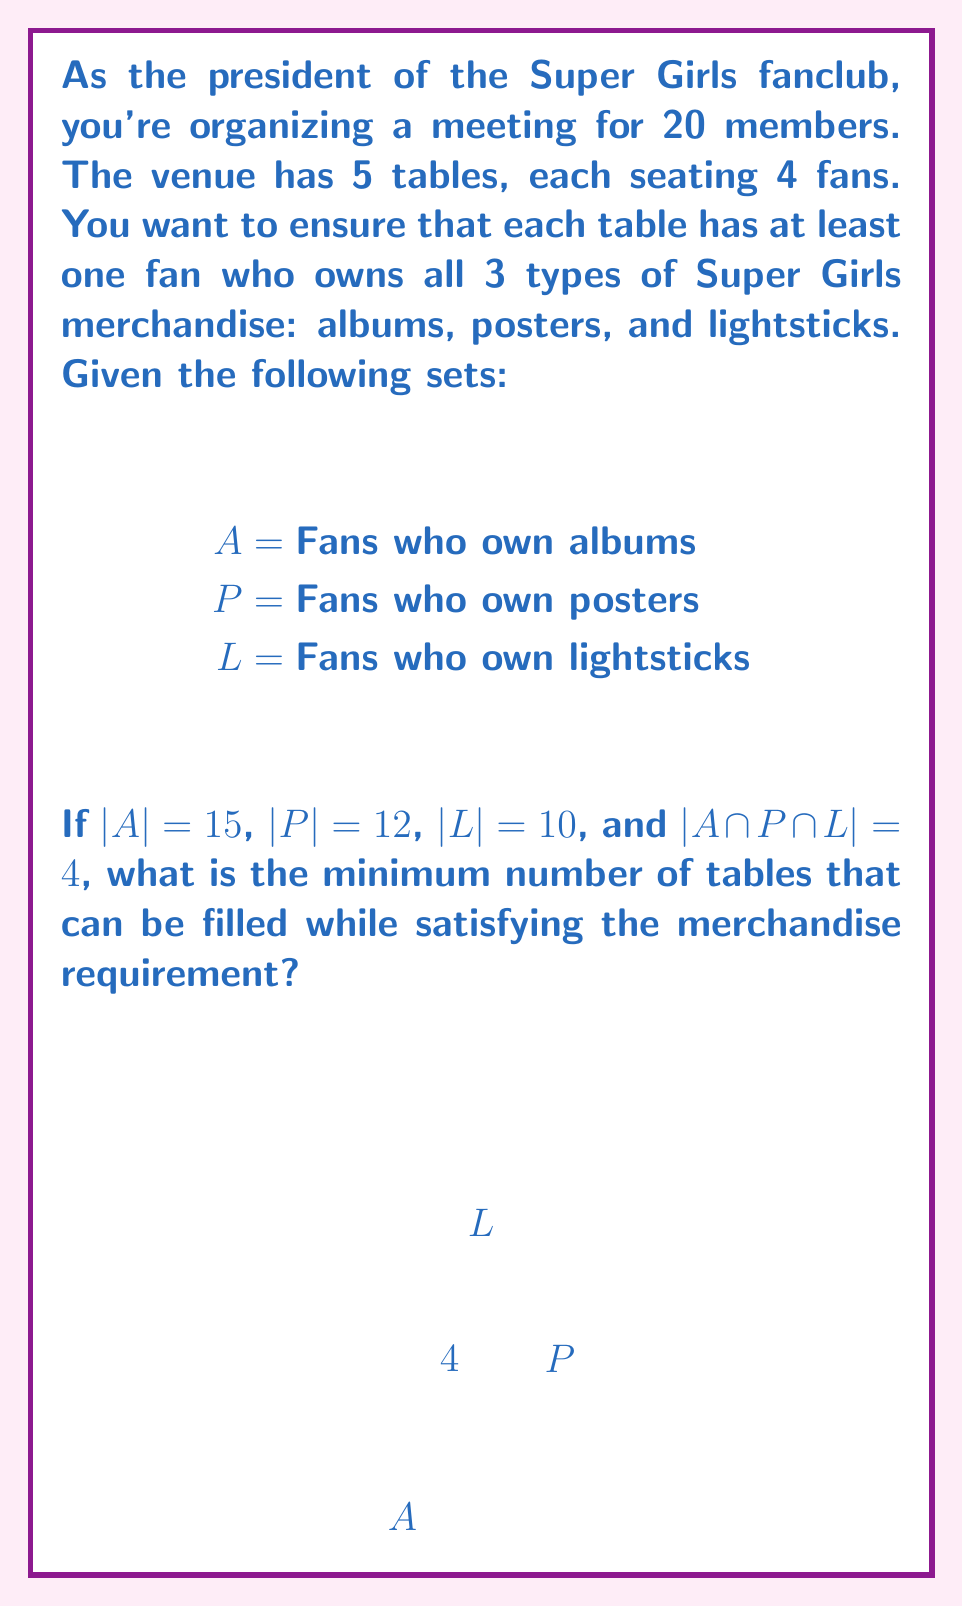Could you help me with this problem? Let's approach this step-by-step:

1) First, we need to find the number of fans who own all three types of merchandise. This is given by $|A \cap P \cap L| = 4$.

2) Now, we need to distribute these 4 fans among the tables. Since each table needs at least one fan with all merchandise, we can fill a maximum of 4 tables.

3) To check if we can fill the 5th table, we need to determine if there are any fans left who own all three types of merchandise.

4) To do this, we can use the Inclusion-Exclusion Principle:

   $$|A \cup P \cup L| = |A| + |P| + |L| - |A \cap P| - |A \cap L| - |P \cap L| + |A \cap P \cap L|$$

5) We know $|A| = 15$, $|P| = 12$, $|L| = 10$, and $|A \cap P \cap L| = 4$. We need to find $|A \cap P|$, $|A \cap L|$, and $|P \cap L|$.

6) Let's assume these intersections are as large as possible. The maximum possible values are:

   $|A \cap P| \leq \min(|A|, |P|) = \min(15, 12) = 12$
   $|A \cap L| \leq \min(|A|, |L|) = \min(15, 10) = 10$
   $|P \cap L| \leq \min(|P|, |L|) = \min(12, 10) = 10$

7) Substituting these maximum values into the equation:

   $$|A \cup P \cup L| \geq 15 + 12 + 10 - 12 - 10 - 10 + 4 = 9$$

8) This means that even in the best-case scenario, there are at most 9 fans who own at least one type of merchandise.

9) Since there are 20 fans in total, and at most 9 own at least one type of merchandise, there must be at least 11 fans who don't own any merchandise.

10) These 11 fans cannot be seated at a table that satisfies the merchandise requirement.

11) Therefore, we can only fill 4 tables while satisfying the requirement.
Answer: 4 tables 